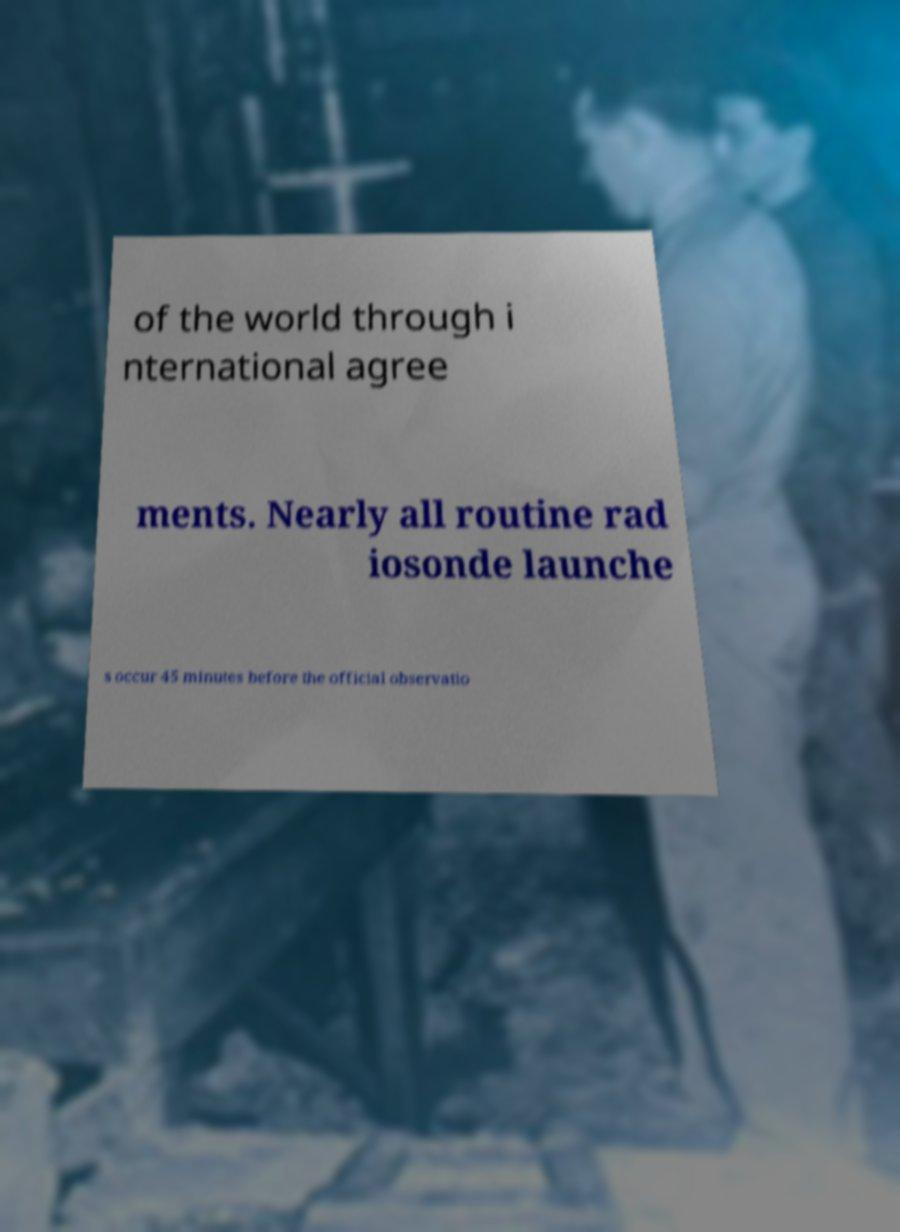Could you assist in decoding the text presented in this image and type it out clearly? of the world through i nternational agree ments. Nearly all routine rad iosonde launche s occur 45 minutes before the official observatio 